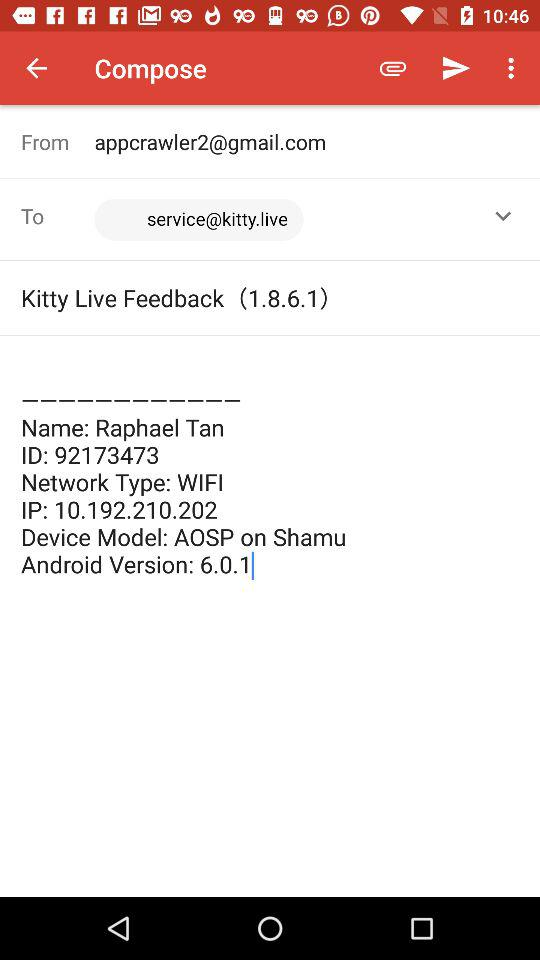What is the device model name? The device model name is "AOSP on Shamu". 